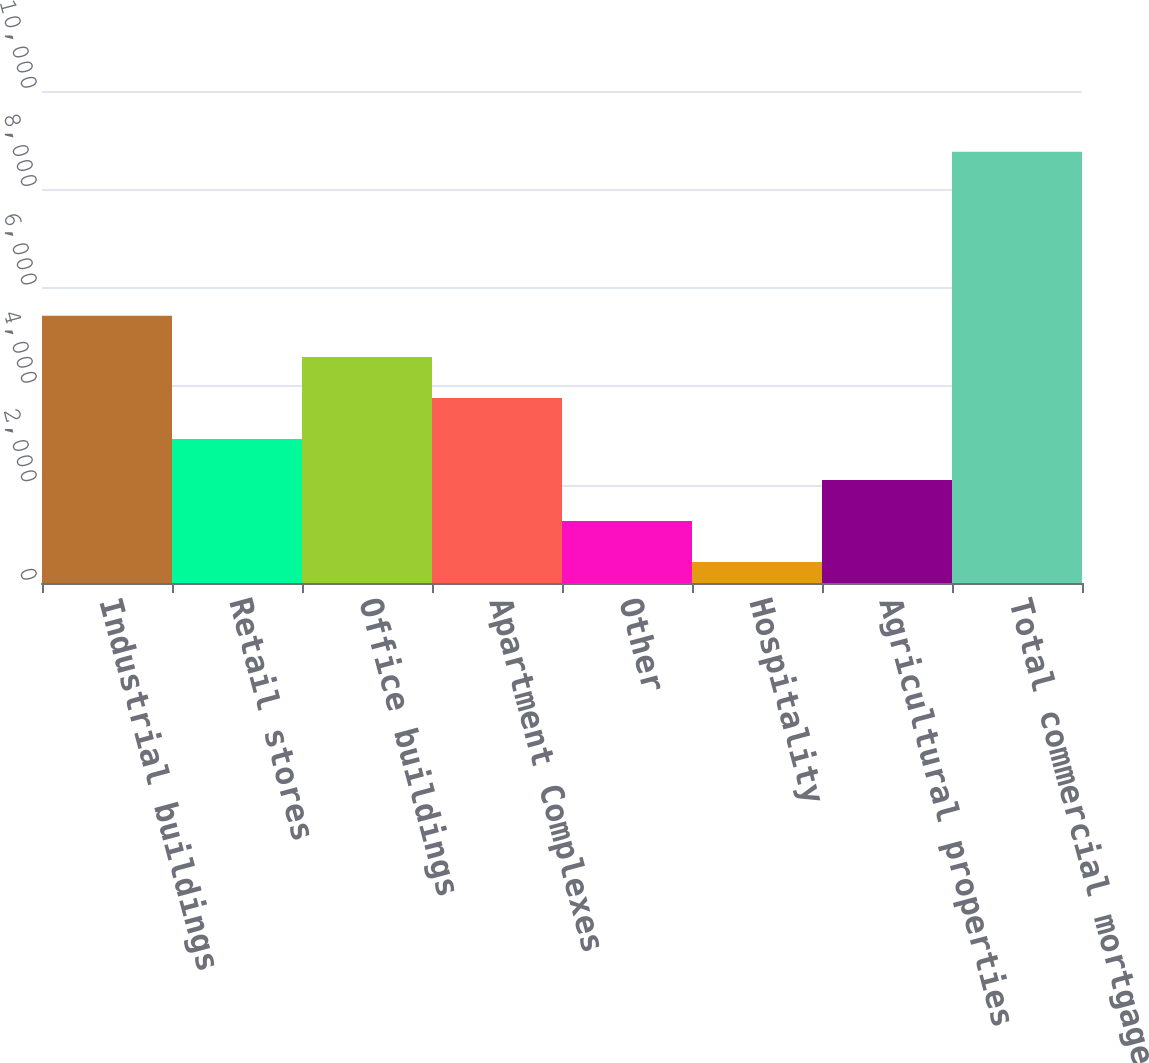Convert chart. <chart><loc_0><loc_0><loc_500><loc_500><bar_chart><fcel>Industrial buildings<fcel>Retail stores<fcel>Office buildings<fcel>Apartment Complexes<fcel>Other<fcel>Hospitality<fcel>Agricultural properties<fcel>Total commercial mortgage<nl><fcel>5429.8<fcel>2928.4<fcel>4596<fcel>3762.2<fcel>1260.8<fcel>427<fcel>2094.6<fcel>8765<nl></chart> 